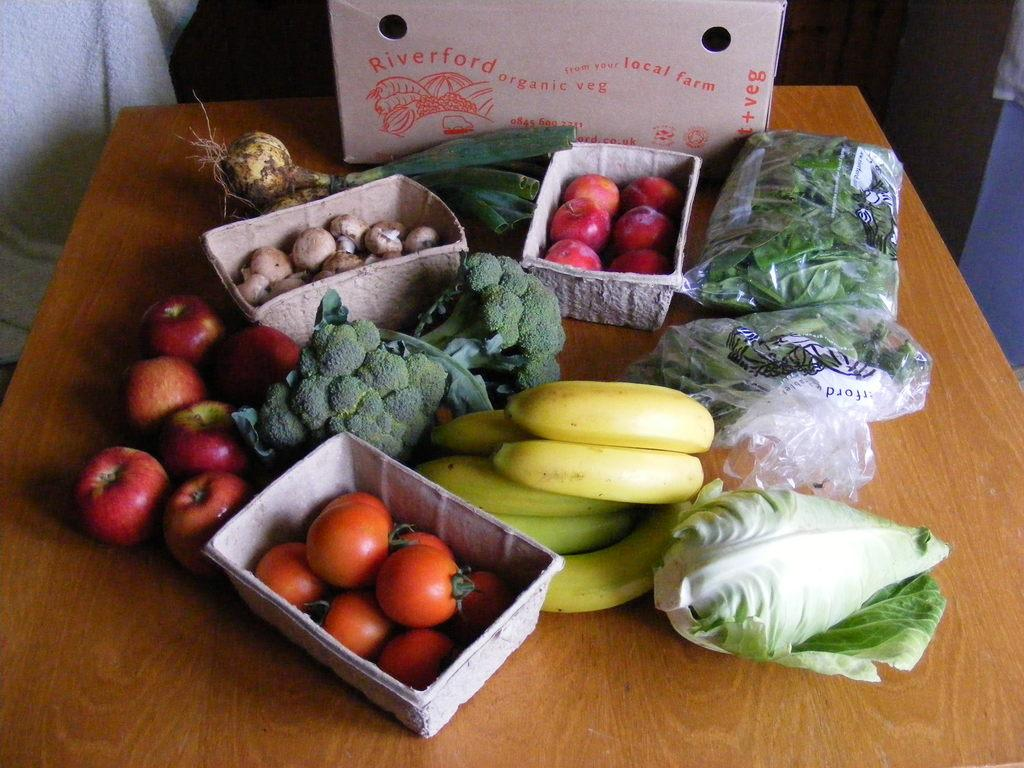What types of food items are visible in the image? There are fruits and vegetables in the image. What is the container for these food items? There is a cardboard box in the image. Where are these items located? All of these objects are on a table. How does the pollution affect the rabbit in the image? There is no rabbit or pollution present in the image. 